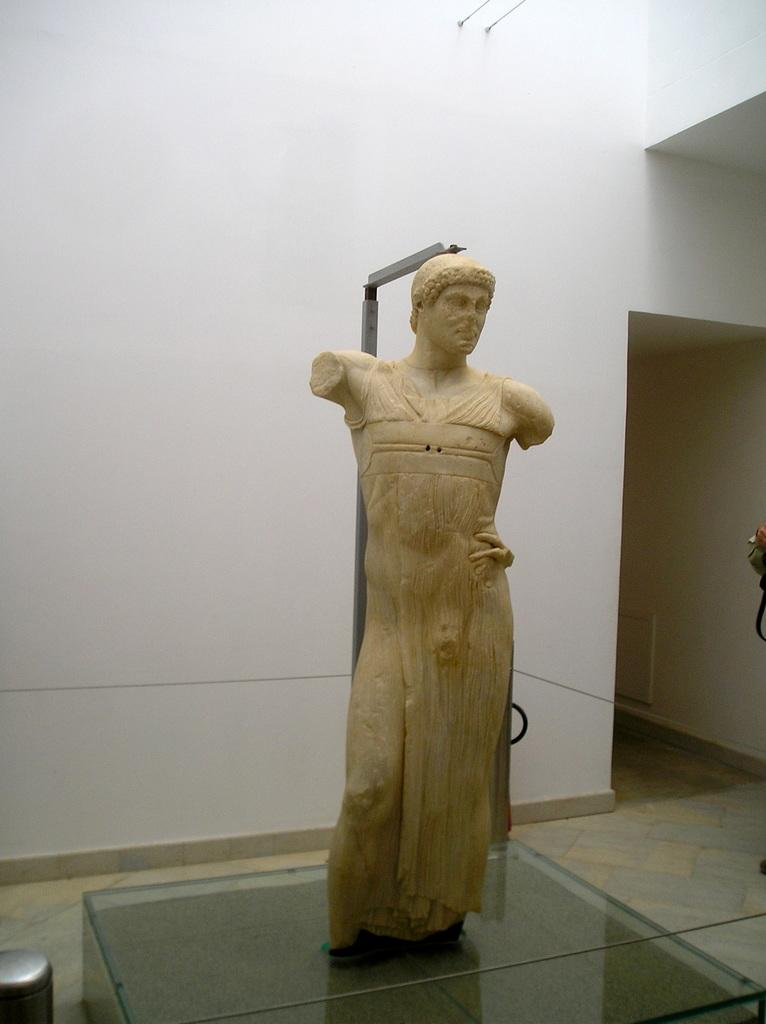What is the main subject on the glass surface in the image? There is a sculpture on a glass surface in the image. What other objects can be seen in the image? There is a pole and a wall in the image. Can you see any veins in the sculpture in the image? There are no veins present in the sculpture, as it is an inanimate object made of a material such as stone, metal, or wood. 